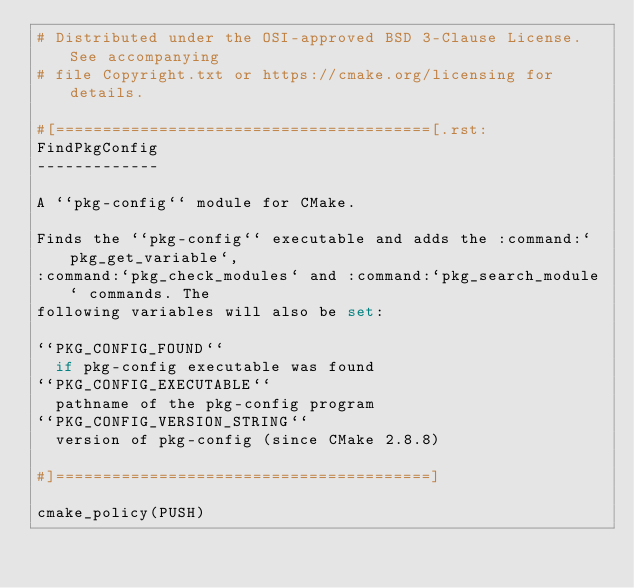<code> <loc_0><loc_0><loc_500><loc_500><_CMake_># Distributed under the OSI-approved BSD 3-Clause License.  See accompanying
# file Copyright.txt or https://cmake.org/licensing for details.

#[========================================[.rst:
FindPkgConfig
-------------

A ``pkg-config`` module for CMake.

Finds the ``pkg-config`` executable and adds the :command:`pkg_get_variable`,
:command:`pkg_check_modules` and :command:`pkg_search_module` commands. The
following variables will also be set:

``PKG_CONFIG_FOUND``
  if pkg-config executable was found
``PKG_CONFIG_EXECUTABLE``
  pathname of the pkg-config program
``PKG_CONFIG_VERSION_STRING``
  version of pkg-config (since CMake 2.8.8)

#]========================================]

cmake_policy(PUSH)</code> 